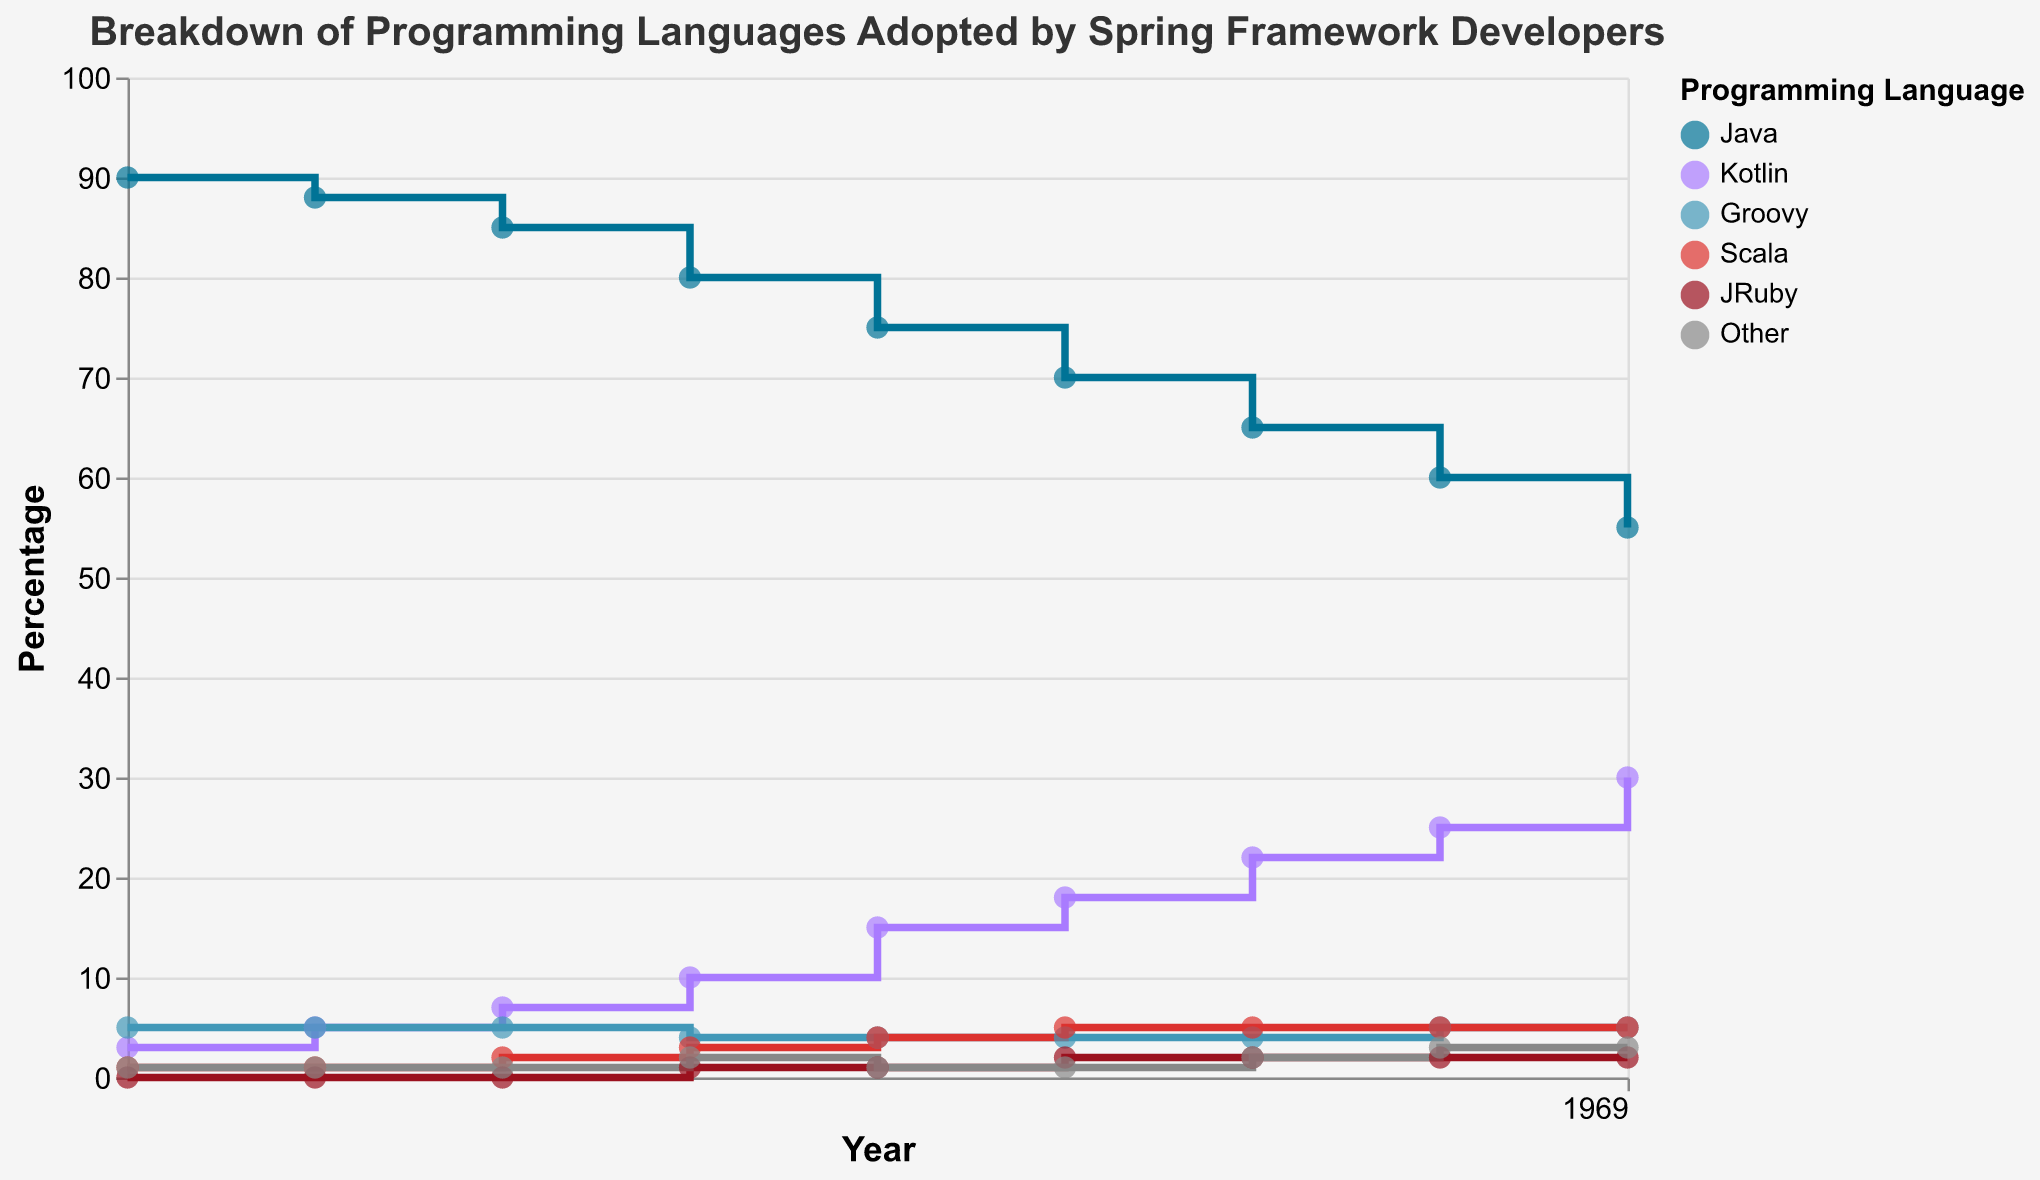What is the title of the plot? The title of the plot is displayed at the top of the figure. It reads "Breakdown of Programming Languages Adopted by Spring Framework Developers" in a large, bold font.
Answer: Breakdown of Programming Languages Adopted by Spring Framework Developers How many different programming languages are tracked in the figure? The plot uses different colors represented in the legend to show the programming languages; there are six languages: Java, Kotlin, Groovy, Scala, JRuby, and Other.
Answer: 6 Which programming language had the highest adoption in 2015? By observing the lines and points on the plot, the Java line starts highest at 90% in 2015.
Answer: Java In what year did Kotlin surpass 20% adoption? By examining the trajectory of the Kotlin line (purple), it crosses the 20% mark between 2020 and reaches 22% in 2021.
Answer: 2021 How did the adoption of Scala change from 2015 to 2023? Scala's adoption rate starts at 1% in 2015. By following the red line through the years, it rises to 5% by 2020 and remains constant through 2023.
Answer: It increased from 1% to 5% What is the percentage difference in Java adoption between 2015 and 2023? The Java line starts at 90% in 2015 and falls to 55% in 2023. The difference in percentages is calculated as 90 - 55.
Answer: 35% In which year did Groovy's adoption rate decrease compared to the previous year? Observing the Groovy line (blue), it starts at 5% in 2015, unchanged until 2018 when it drops to 4%.
Answer: 2018 Which language shows the most significant growth from 2015 to 2023? By comparing the start and endpoints of each line, Kotlin shows notable growth from 3% to 30%. No other language exhibits such a significant rise.
Answer: Kotlin Which two languages were consistently adopted by 5% or fewer developers each year from 2015 to 2023? By checking all lines across the years, Groovy, Scala, JRuby, and Other always remain at or below 5%.
Answer: Groovy, Scala, JRuby, Other 